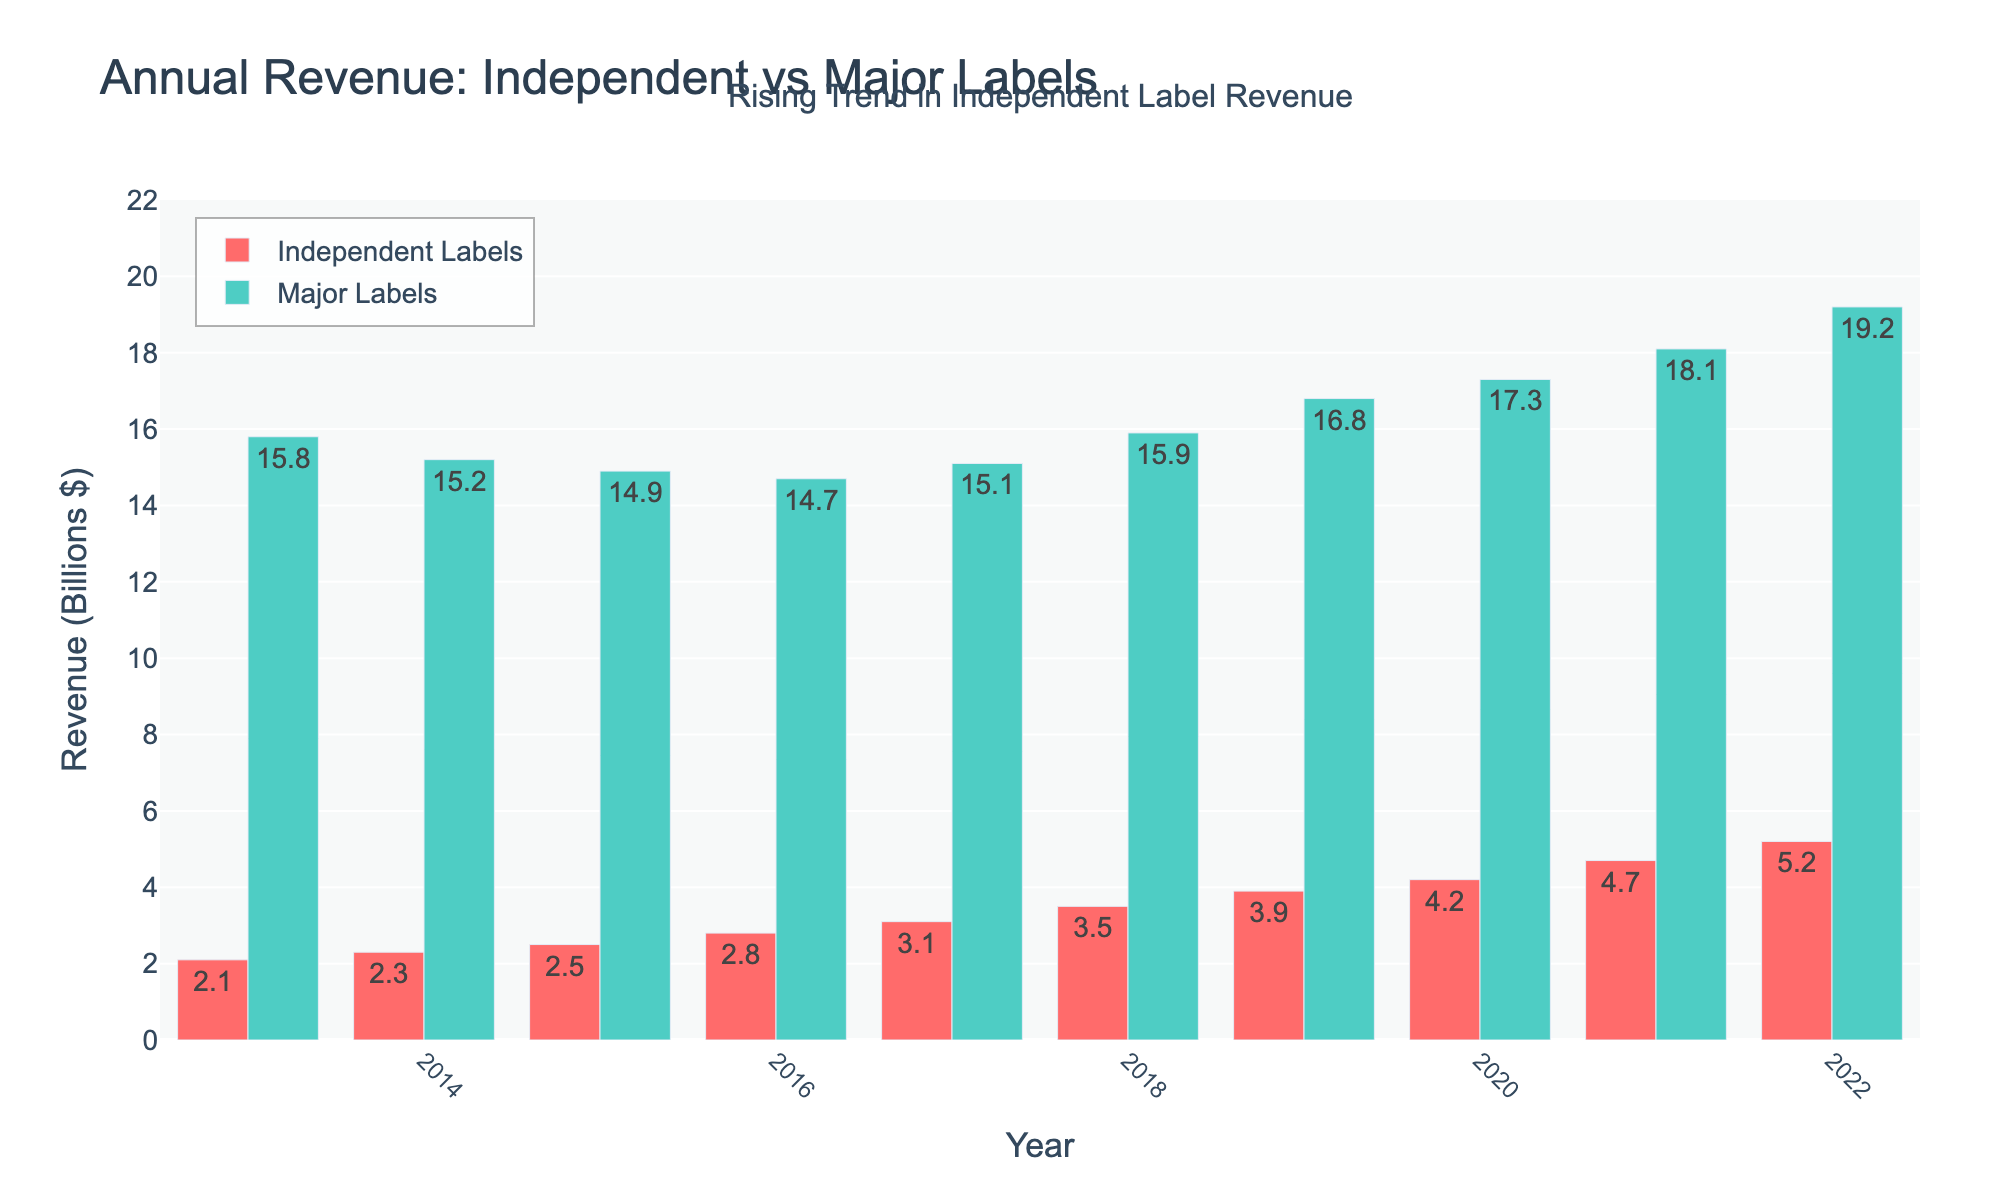What was the revenue of independent labels in 2019? Look at the bar representing 2019 for independent labels, it's labeled "3.9"
Answer: 3.9 billion dollars Which year had the closest revenue between independent and major labels? Calculate the difference in revenue for each year and compare. The year with the smallest difference is 2017 with a difference of $12 billion ($15.1 billion for major labels - $3.1 billion for independent labels).
Answer: 2017 What was the average annual revenue for major labels over the past decade? Sum up the revenues for major labels from 2013 to 2022 and divide by 10: (15.8 + 15.2 + 14.9 + 14.7 + 15.1 + 15.9 + 16.8 + 17.3 + 18.1 + 19.2) / 10 = 16.3 billion dollars
Answer: 16.3 billion dollars In which year did independent labels see the highest increase in revenue from the previous year? Calculate the year-on-year difference for independent labels and find the maximum increase. The highest increase was from 2021 to 2022 with an increase of $0.5 billion ($5.2 billion - $4.7 billion).
Answer: 2022 Between the years 2017 and 2020, what was the total revenue for independent labels? Sum the revenues for independent labels from 2017 to 2020: 3.1 + 3.5 + 3.9 + 4.2 = 14.7 billion dollars
Answer: 14.7 billion dollars Compare the revenue growth rate from 2013 to 2022 for independent labels and major labels. Which had a higher growth rate? Calculate the growth rate for both:
Independent: (5.2 - 2.1) / 2.1 = 148%
Major: (19.2 - 15.8) / 15.8 = 21.5%
The independent labels had a higher growth rate.
Answer: Independent labels What color represents the revenue of major labels in the chart? Observe the bar colors in the chart and refer to the legend. The bars for major labels are green.
Answer: Green What visual trend is highlighted by the chart’s annotation? The annotation at the top of the chart notes a "Rising Trend in Independent Label Revenue", indicating increasing revenues for independent labels over time.
Answer: Rising Trend in Independent Label Revenue Comparing the revenues in 2020, how much more did major labels earn compared to independent labels? For 2020, subtract the revenue of independent labels from that of major labels: 17.3 - 4.2 = 13.1 billion dollars.
Answer: 13.1 billion dollars Between 2016 and 2018, did the revenue for major labels increase or decrease? By how much? Compare the revenue for major labels in 2016 and 2018: 15.9 (2018) - 14.7 (2016) = 1.2 billion dollars increase.
Answer: Increase by 1.2 billion dollars 